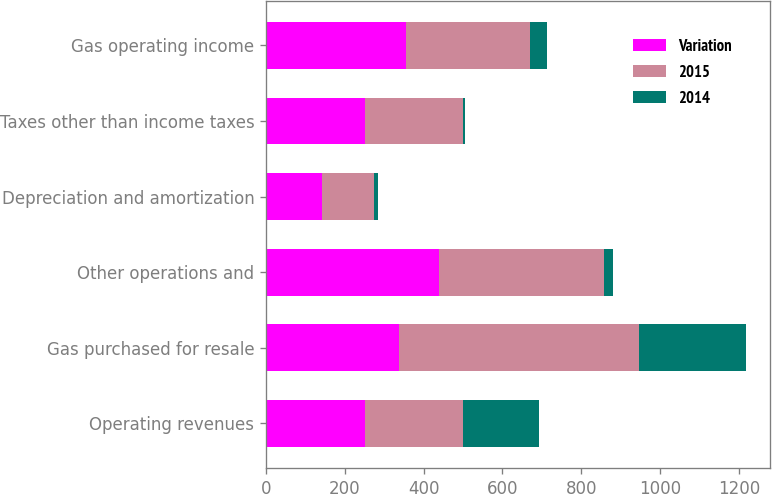Convert chart to OTSL. <chart><loc_0><loc_0><loc_500><loc_500><stacked_bar_chart><ecel><fcel>Operating revenues<fcel>Gas purchased for resale<fcel>Other operations and<fcel>Depreciation and amortization<fcel>Taxes other than income taxes<fcel>Gas operating income<nl><fcel>Variation<fcel>250<fcel>337<fcel>440<fcel>142<fcel>252<fcel>356<nl><fcel>2015<fcel>250<fcel>609<fcel>418<fcel>132<fcel>248<fcel>314<nl><fcel>2014<fcel>194<fcel>272<fcel>22<fcel>10<fcel>4<fcel>42<nl></chart> 